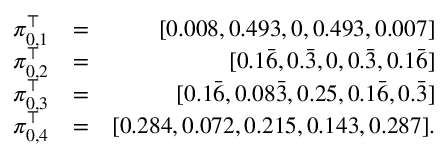Convert formula to latex. <formula><loc_0><loc_0><loc_500><loc_500>\begin{array} { r l r } { \pi _ { 0 , 1 } ^ { \top } } & { = } & { [ 0 . 0 0 8 , 0 . 4 9 3 , 0 , 0 . 4 9 3 , 0 . 0 0 7 ] } \\ { \pi _ { 0 , 2 } ^ { \top } } & { = } & { [ 0 . 1 \bar { 6 } , 0 . \bar { 3 } , 0 , 0 . \bar { 3 } , 0 . 1 \bar { 6 } ] } \\ { \pi _ { 0 , 3 } ^ { \top } } & { = } & { [ 0 . 1 \bar { 6 } , 0 . 0 8 \bar { 3 } , 0 . 2 5 , 0 . 1 \bar { 6 } , 0 . \bar { 3 } ] } \\ { \pi _ { 0 , 4 } ^ { \top } } & { = } & { [ 0 . 2 8 4 , 0 . 0 7 2 , 0 . 2 1 5 , 0 . 1 4 3 , 0 . 2 8 7 ] . } \end{array}</formula> 